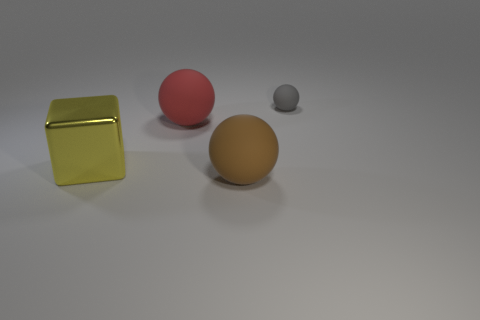Add 4 big brown matte things. How many objects exist? 8 Subtract all blocks. How many objects are left? 3 Subtract 0 blue balls. How many objects are left? 4 Subtract all large red shiny spheres. Subtract all big red rubber objects. How many objects are left? 3 Add 2 big yellow cubes. How many big yellow cubes are left? 3 Add 1 small objects. How many small objects exist? 2 